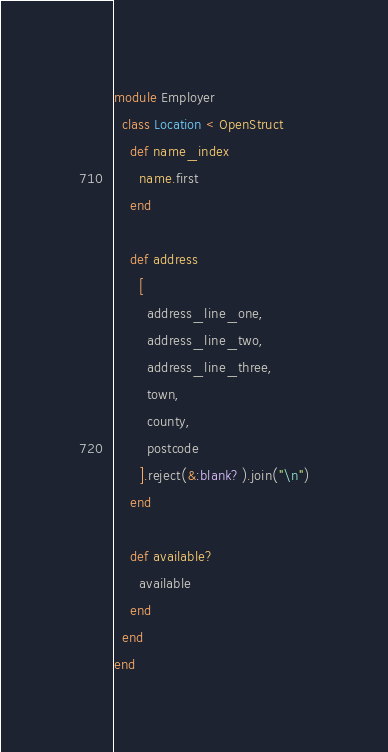Convert code to text. <code><loc_0><loc_0><loc_500><loc_500><_Ruby_>module Employer
  class Location < OpenStruct
    def name_index
      name.first
    end

    def address
      [
        address_line_one,
        address_line_two,
        address_line_three,
        town,
        county,
        postcode
      ].reject(&:blank?).join("\n")
    end

    def available?
      available
    end
  end
end
</code> 